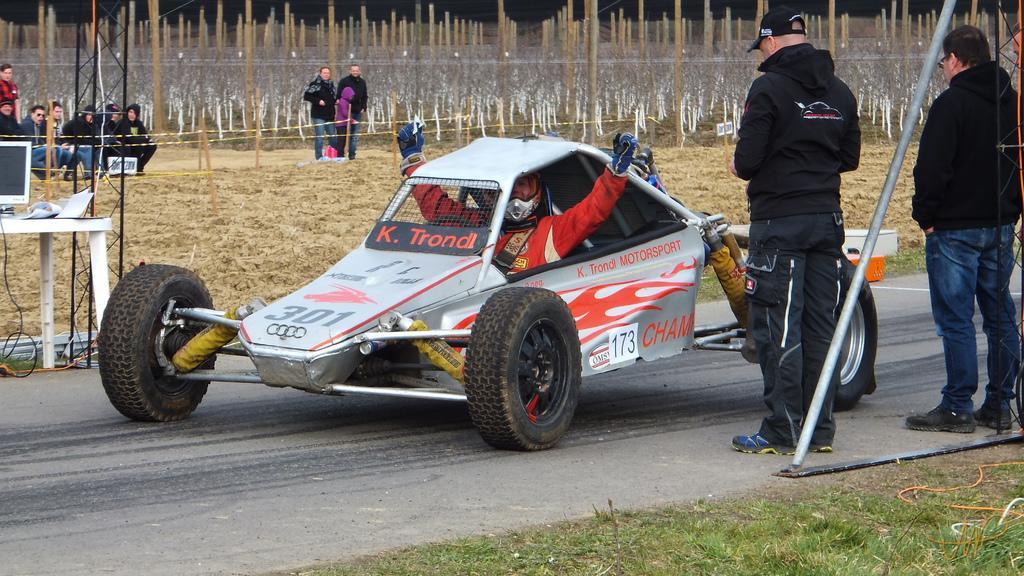Can you describe this image briefly? In this image we can see a vehicle on the road. On the vehicle something is written. Also there is a person wearing helmet and gloves is sitting in the vehicle. Near to the vehicle two persons are standing. One person is wearing a cap. Also there is a rod. On the left side there is a table. On the table there is a computer and some other items. In the back there are few people standing and few people are sitting. On the ground there is grass. In the background there are poles. 